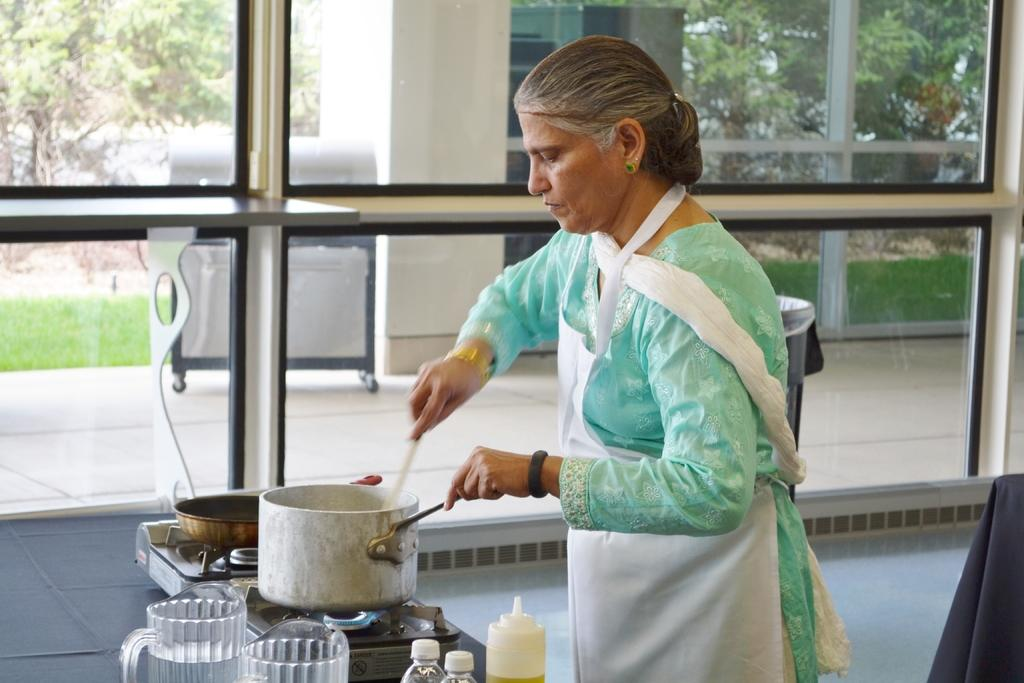What is the woman in the image doing? The woman is cooking on a stove. What is the woman wearing? The woman is wearing a green dress. What type of wall is present in the image? There is a glass wall in the image. What can be seen outside the glass wall? Trees are visible outside the glass wall. How many toys are on the stove in the image? There are no toys present on the stove in the image; the woman is cooking. Is the woman crying while cooking in the image? There is no indication in the image that the woman is crying; she is focused on cooking. 